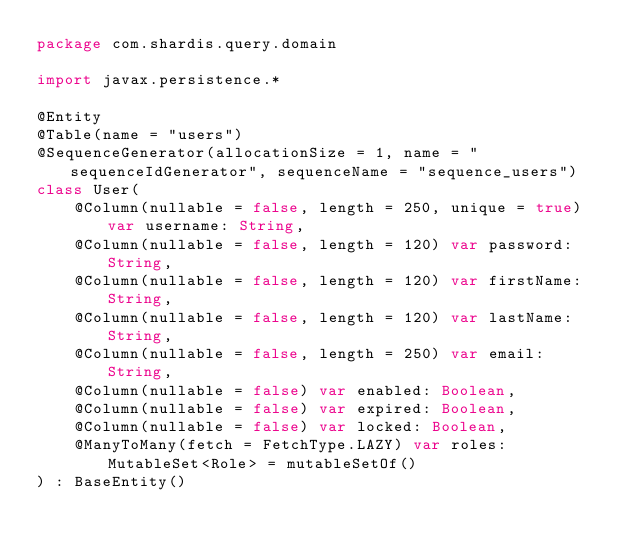Convert code to text. <code><loc_0><loc_0><loc_500><loc_500><_Kotlin_>package com.shardis.query.domain

import javax.persistence.*

@Entity
@Table(name = "users")
@SequenceGenerator(allocationSize = 1, name = "sequenceIdGenerator", sequenceName = "sequence_users")
class User(
    @Column(nullable = false, length = 250, unique = true) var username: String,
    @Column(nullable = false, length = 120) var password: String,
    @Column(nullable = false, length = 120) var firstName: String,
    @Column(nullable = false, length = 120) var lastName: String,
    @Column(nullable = false, length = 250) var email: String,
    @Column(nullable = false) var enabled: Boolean,
    @Column(nullable = false) var expired: Boolean,
    @Column(nullable = false) var locked: Boolean,
    @ManyToMany(fetch = FetchType.LAZY) var roles: MutableSet<Role> = mutableSetOf()
) : BaseEntity()
</code> 